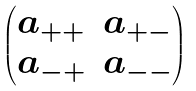Convert formula to latex. <formula><loc_0><loc_0><loc_500><loc_500>\begin{pmatrix} a _ { + + } & a _ { + - } \\ a _ { - + } & a _ { - - } \end{pmatrix}</formula> 